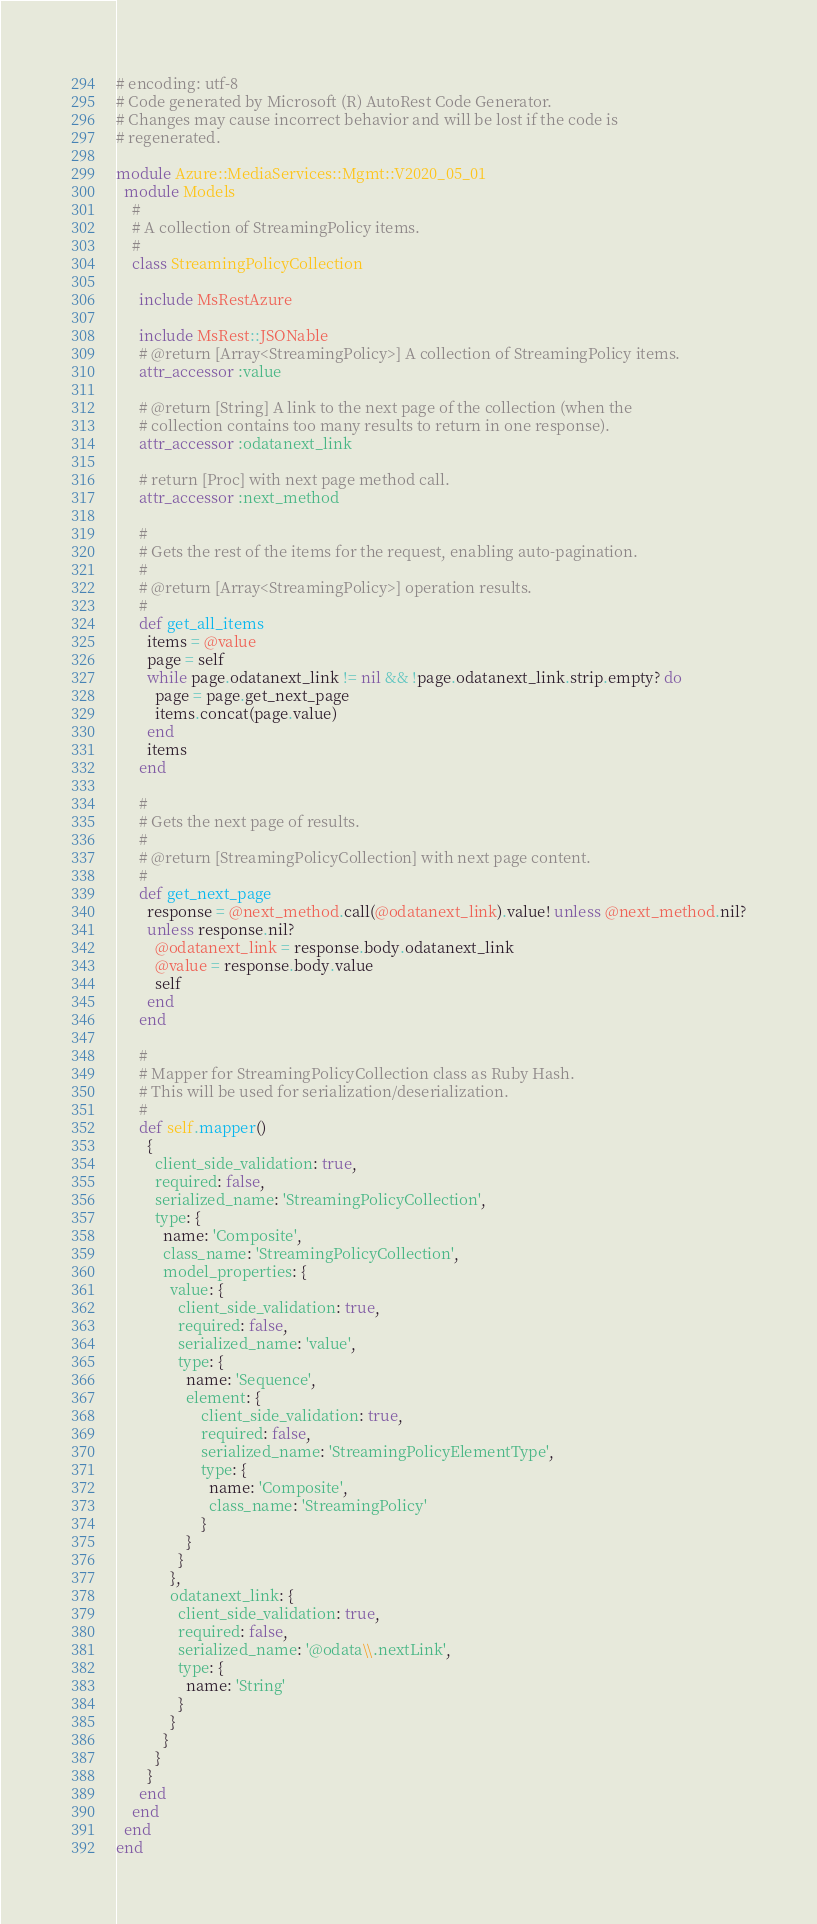Convert code to text. <code><loc_0><loc_0><loc_500><loc_500><_Ruby_># encoding: utf-8
# Code generated by Microsoft (R) AutoRest Code Generator.
# Changes may cause incorrect behavior and will be lost if the code is
# regenerated.

module Azure::MediaServices::Mgmt::V2020_05_01
  module Models
    #
    # A collection of StreamingPolicy items.
    #
    class StreamingPolicyCollection

      include MsRestAzure

      include MsRest::JSONable
      # @return [Array<StreamingPolicy>] A collection of StreamingPolicy items.
      attr_accessor :value

      # @return [String] A link to the next page of the collection (when the
      # collection contains too many results to return in one response).
      attr_accessor :odatanext_link

      # return [Proc] with next page method call.
      attr_accessor :next_method

      #
      # Gets the rest of the items for the request, enabling auto-pagination.
      #
      # @return [Array<StreamingPolicy>] operation results.
      #
      def get_all_items
        items = @value
        page = self
        while page.odatanext_link != nil && !page.odatanext_link.strip.empty? do
          page = page.get_next_page
          items.concat(page.value)
        end
        items
      end

      #
      # Gets the next page of results.
      #
      # @return [StreamingPolicyCollection] with next page content.
      #
      def get_next_page
        response = @next_method.call(@odatanext_link).value! unless @next_method.nil?
        unless response.nil?
          @odatanext_link = response.body.odatanext_link
          @value = response.body.value
          self
        end
      end

      #
      # Mapper for StreamingPolicyCollection class as Ruby Hash.
      # This will be used for serialization/deserialization.
      #
      def self.mapper()
        {
          client_side_validation: true,
          required: false,
          serialized_name: 'StreamingPolicyCollection',
          type: {
            name: 'Composite',
            class_name: 'StreamingPolicyCollection',
            model_properties: {
              value: {
                client_side_validation: true,
                required: false,
                serialized_name: 'value',
                type: {
                  name: 'Sequence',
                  element: {
                      client_side_validation: true,
                      required: false,
                      serialized_name: 'StreamingPolicyElementType',
                      type: {
                        name: 'Composite',
                        class_name: 'StreamingPolicy'
                      }
                  }
                }
              },
              odatanext_link: {
                client_side_validation: true,
                required: false,
                serialized_name: '@odata\\.nextLink',
                type: {
                  name: 'String'
                }
              }
            }
          }
        }
      end
    end
  end
end
</code> 